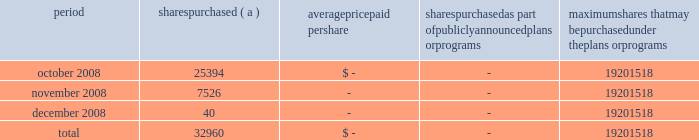Annual report on form 10-k 108 fifth third bancorp part ii item 5 .
Market for registrant 2019s common equity , related stockholder matters and issuer purchases of equity securities the information required by this item is included in the corporate information found on the inside of the back cover and in the discussion of dividend limitations that the subsidiaries can pay to the bancorp discussed in note 26 of the notes to the consolidated financial statements .
Additionally , as of december 31 , 2008 , the bancorp had approximately 60025 shareholders of record .
Issuer purchases of equity securities period shares purchased average paid per shares purchased as part of publicly announced plans or programs maximum shares that may be purchased under the plans or programs .
( a ) the bancorp repurchased 25394 , 7526 and 40 shares during october , november and december of 2008 in connection with various employee compensation plans of the bancorp .
These purchases are not included against the maximum number of shares that may yet be purchased under the board of directors authorization. .
What was the average monthly shares repurchased in the 4th quarter 2008? 
Computations: (((7526 + 25394) + 40) / 3)
Answer: 10986.66667. 